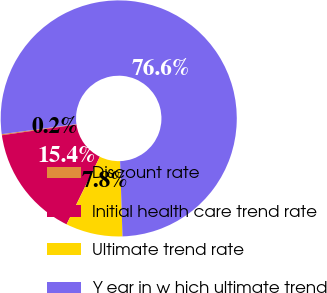<chart> <loc_0><loc_0><loc_500><loc_500><pie_chart><fcel>Discount rate<fcel>Initial health care trend rate<fcel>Ultimate trend rate<fcel>Y ear in w hich ultimate trend<nl><fcel>0.15%<fcel>15.44%<fcel>7.79%<fcel>76.62%<nl></chart> 